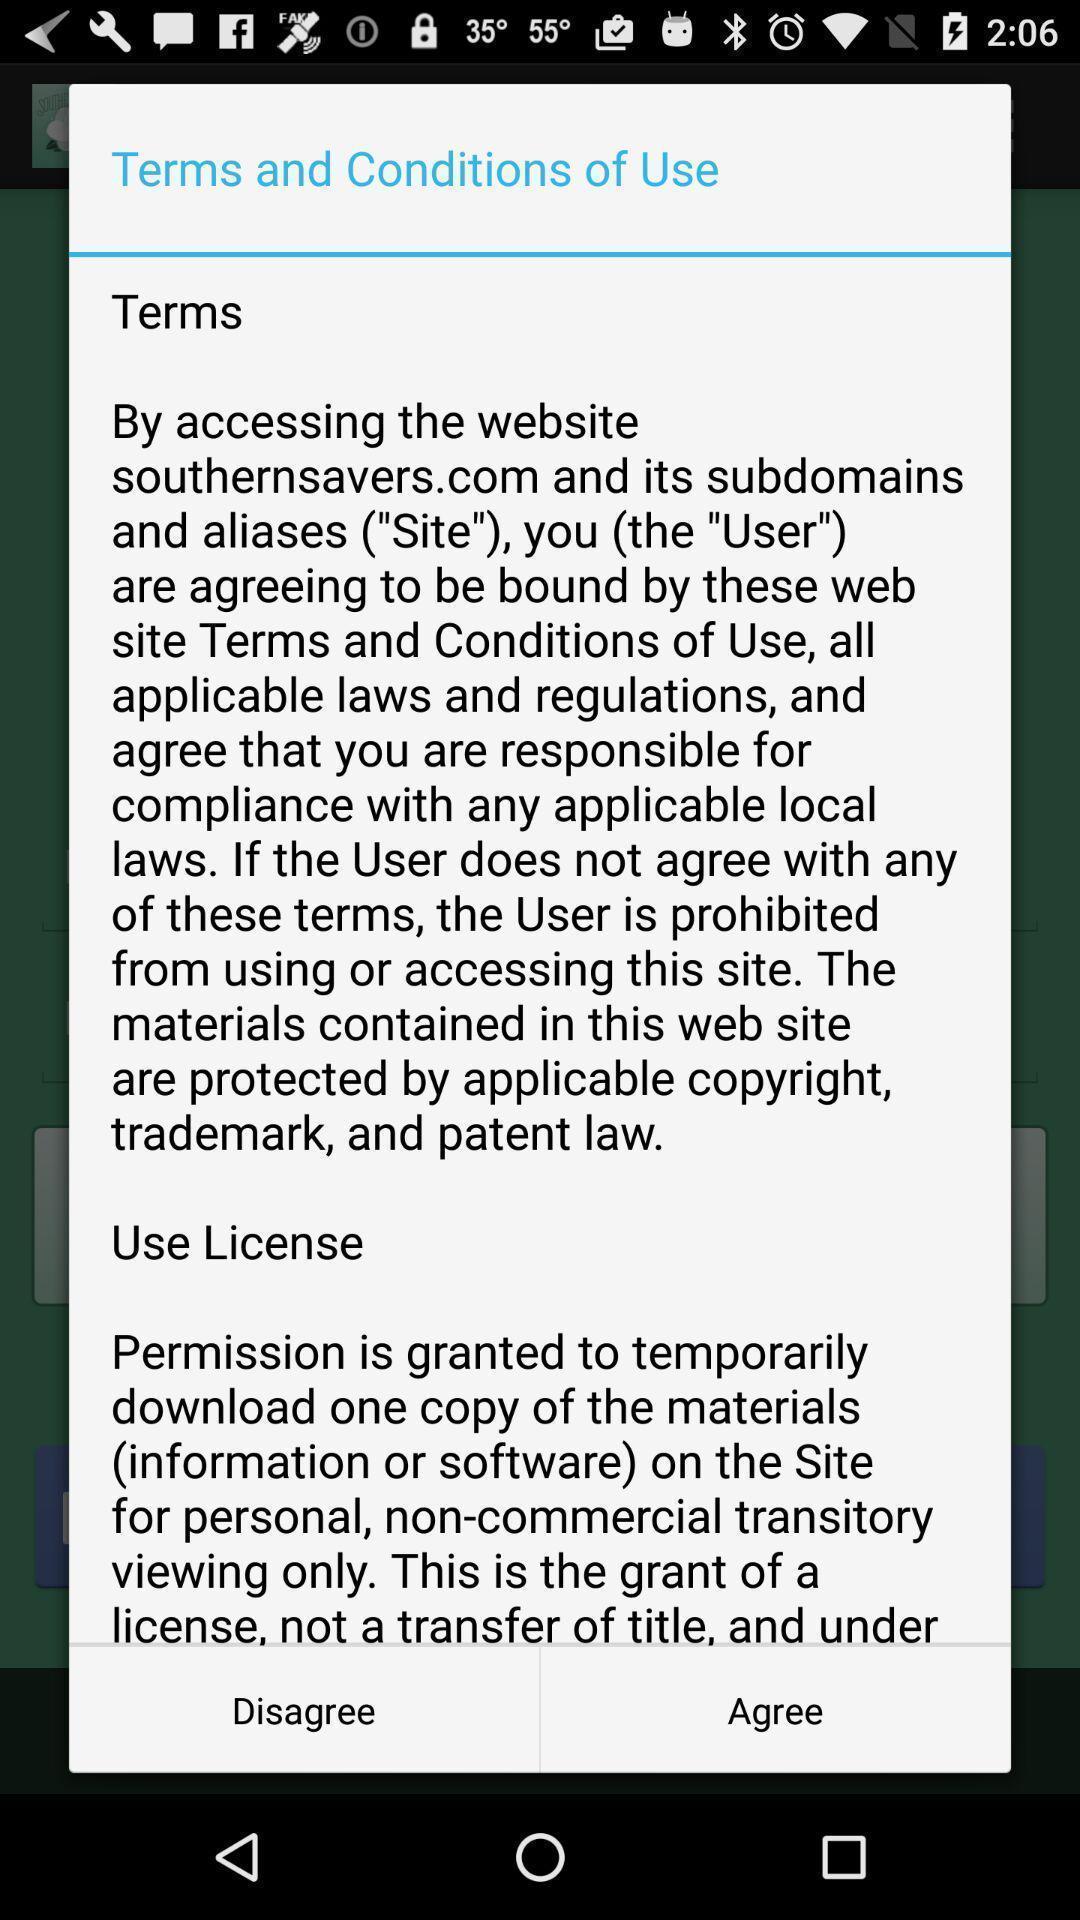Describe the visual elements of this screenshot. Pop-up displaying terms and conditions to agree. 